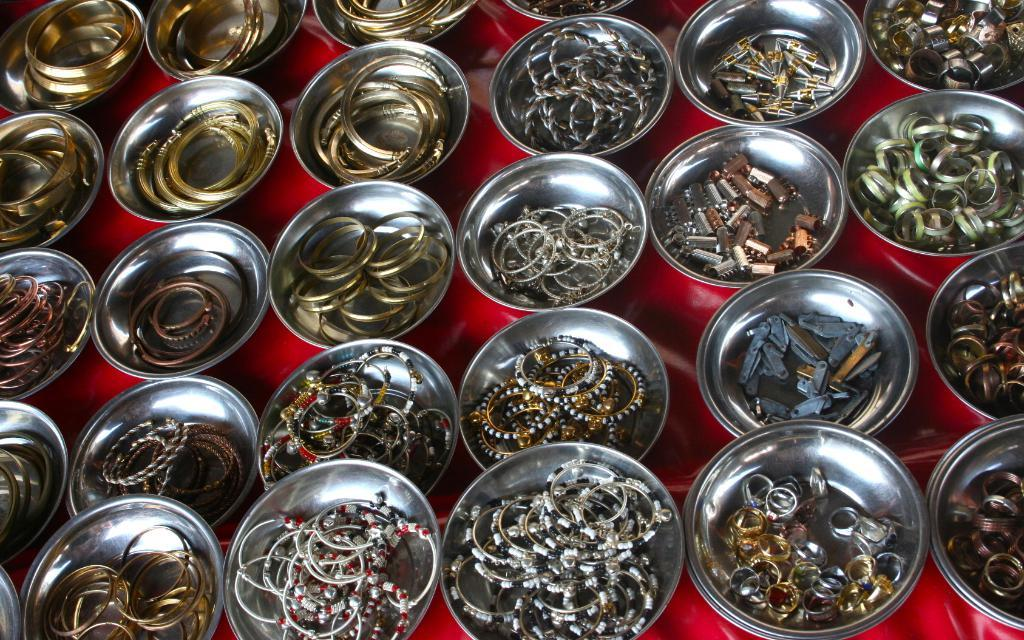What type of furniture is in the image? There is a table in the image. What is covering the table? The table has a table cloth. How many plates are on the table? There are multiple plates on the table. What types of jewelry are present on the plates? Bangles, chains, rings, anklets, and earrings are present on the plates. What type of coal is present on the table in the image? There is no coal present on the table in the image. What type of lip can be seen on the plates in the image? There are no lips present on the plates in the image; they contain jewelry. 